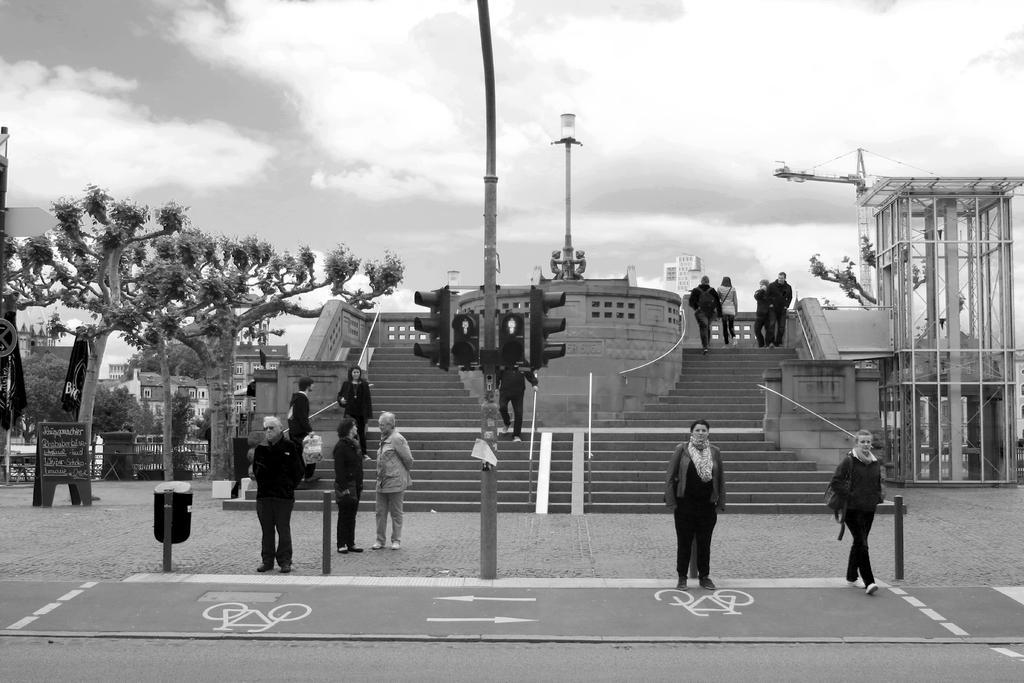Can you describe this image briefly? In this image we can see few persons. Behind the persons we can see stairs, wall and a pole with lights. In the foreground we can see a pole with traffic lights. On the left side, we can see a dustbin, group of trees and buildings. On the right, we can see an object. At the top we can see the sky. 